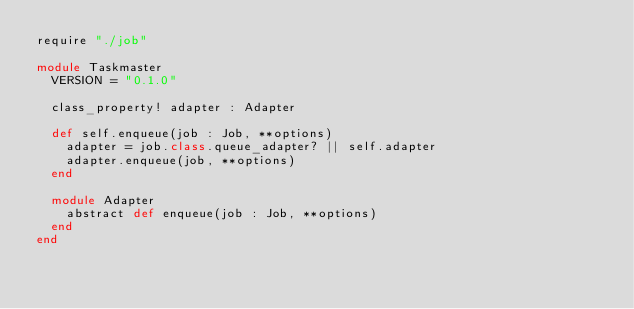<code> <loc_0><loc_0><loc_500><loc_500><_Crystal_>require "./job"

module Taskmaster
  VERSION = "0.1.0"

  class_property! adapter : Adapter

  def self.enqueue(job : Job, **options)
    adapter = job.class.queue_adapter? || self.adapter
    adapter.enqueue(job, **options)
  end

  module Adapter
    abstract def enqueue(job : Job, **options)
  end
end
</code> 